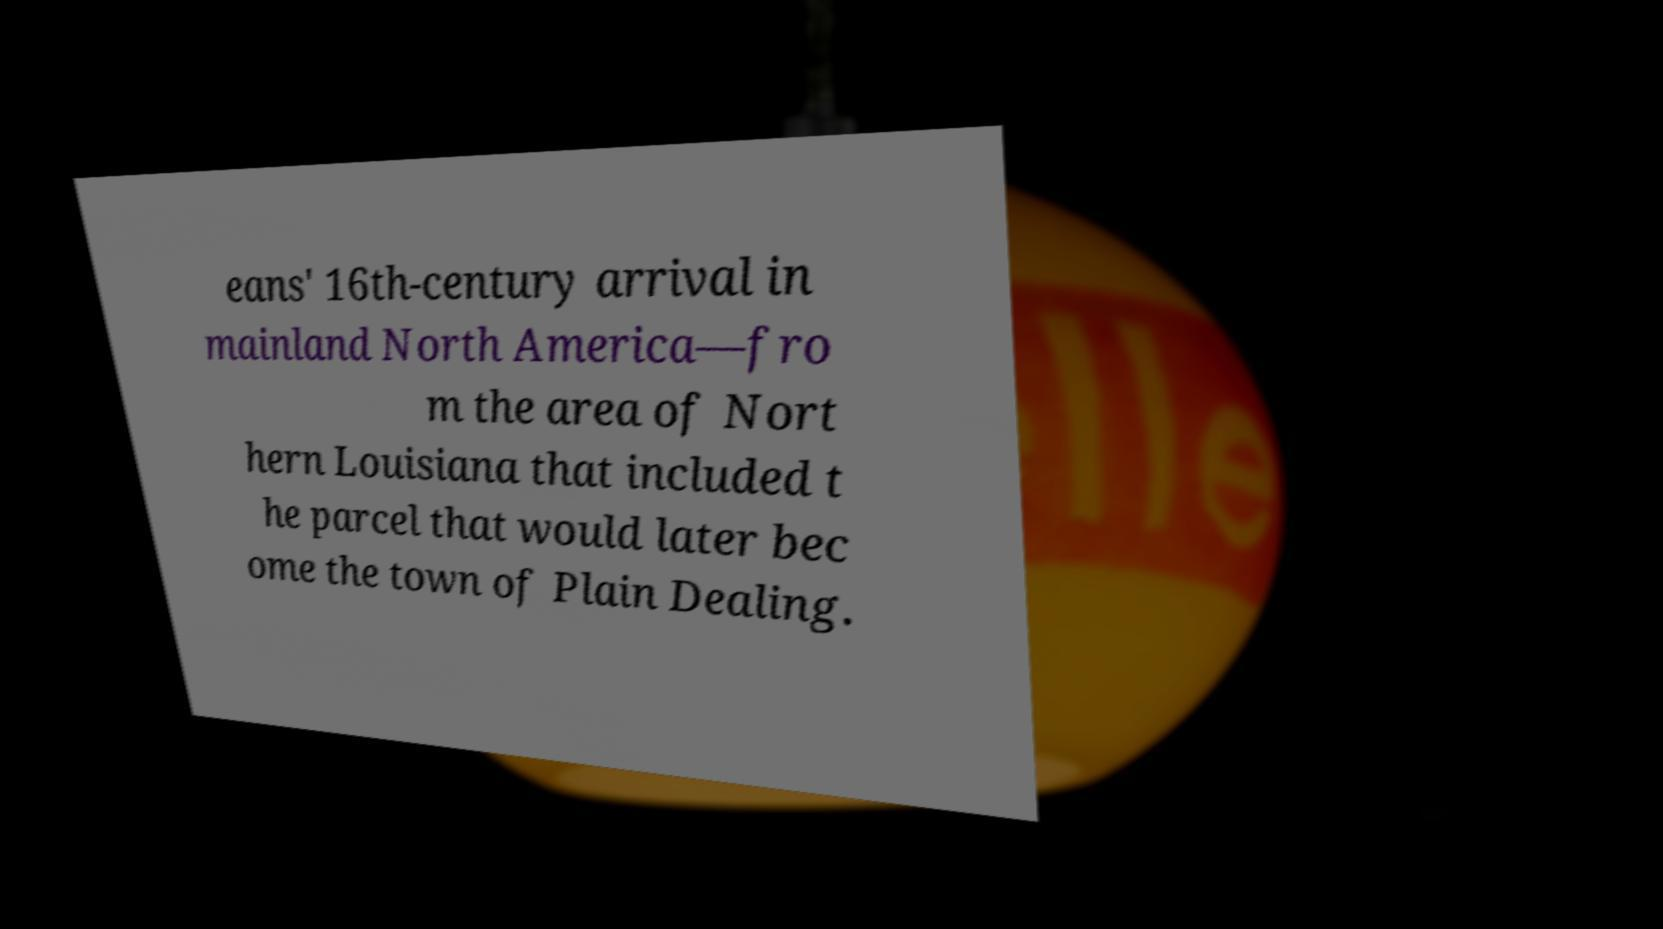Please read and relay the text visible in this image. What does it say? eans' 16th-century arrival in mainland North America—fro m the area of Nort hern Louisiana that included t he parcel that would later bec ome the town of Plain Dealing. 